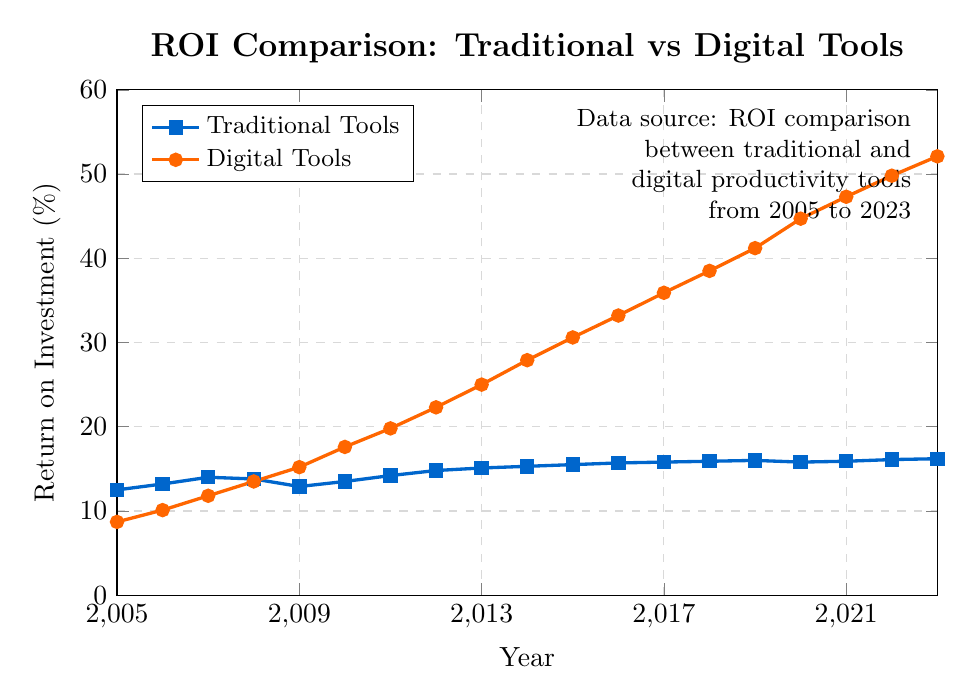What is the ROI for traditional tools in 2023? The figure shows the timeline of the ROI for both traditional and digital tools. Looking at the end of the traditional tools line, we see that the ROI in 2023 is marked at 16.2%.
Answer: 16.2% In which year did the ROI for digital tools first surpass that of traditional tools? Comparing the two lines, we see that the digital tools line crosses above the traditional tools line between 2008 and 2009. Therefore, the year can be pinpointed to 2009.
Answer: 2009 How much did the ROI for digital tools increase from 2005 to 2023? The ROI for digital tools in 2005 is 8.7%, and it increases to 52.1% in 2023. The increase can be calculated as 52.1% - 8.7%.
Answer: 43.4% What is the average ROI for traditional tools between 2010 and 2020? Summing the ROI values for traditional tools from 2010 to 2020 gives (13.5 + 14.2 + 14.8 + 15.1 + 15.3 + 15.5 + 15.7 + 15.8 + 15.9 + 16.0 + 15.8) and there are 11 years. So, the average is (166.6 / 11).
Answer: 15.145% What was the highest ROI value recorded for traditional tools, and in which year? The highest point on the traditional tools line corresponds to the year 2023 with an ROI of 16.2%.
Answer: 16.2% in 2023 Which year showed the greatest increase in ROI for digital tools? The greatest increase is observed by comparing the differences year-on-year. From the data, the largest increase occurred from 2019 (41.2%) to 2020 (44.7%), an increase of 3.5%.
Answer: 2020 How does the ROI trend of traditional tools from 2005 to 2023 compare visually to that of digital tools? Visually, the trend for traditional tools has a relatively steady and slow increase, while the digital tools trend shows a rapid and consistent rise over the years.
Answer: Traditional: steady growth, Digital: rapid growth What is the difference in ROI between traditional and digital tools in 2012? ROI for traditional tools in 2012 is 14.8%, and for digital tools, it is 22.3%. The difference is 22.3% - 14.8%.
Answer: 7.5% 